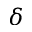<formula> <loc_0><loc_0><loc_500><loc_500>\delta</formula> 